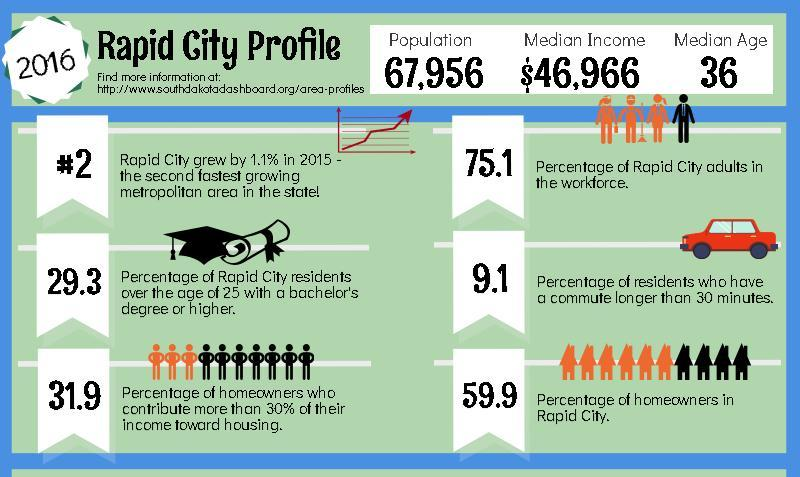What is the inverse percentage of rapid city people having their own homes?
Answer the question with a short phrase. 40.1 What is the inverse percentage of rapid city localities who carry graduation or post-graduation? 70.7 What is the inverse percentage of rapid city people having distance between home and workplace for more than half an hour? 90.9 What is the inverse percentage of rapid city grown-ups in the workforce? 24.9 